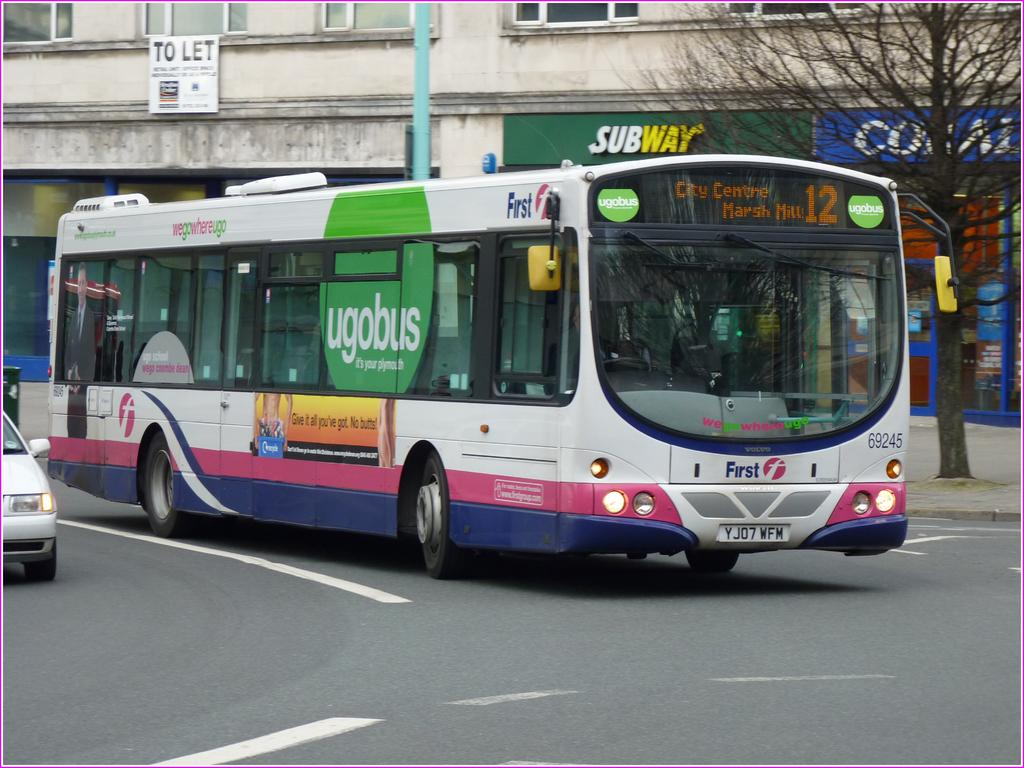<image>
Create a compact narrative representing the image presented. A large bus has a green "ugobus" sign on its side. 